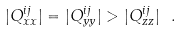<formula> <loc_0><loc_0><loc_500><loc_500>| Q _ { x x } ^ { i j } | = | Q _ { y y } ^ { i j } | > | Q _ { z z } ^ { i j } | \ .</formula> 